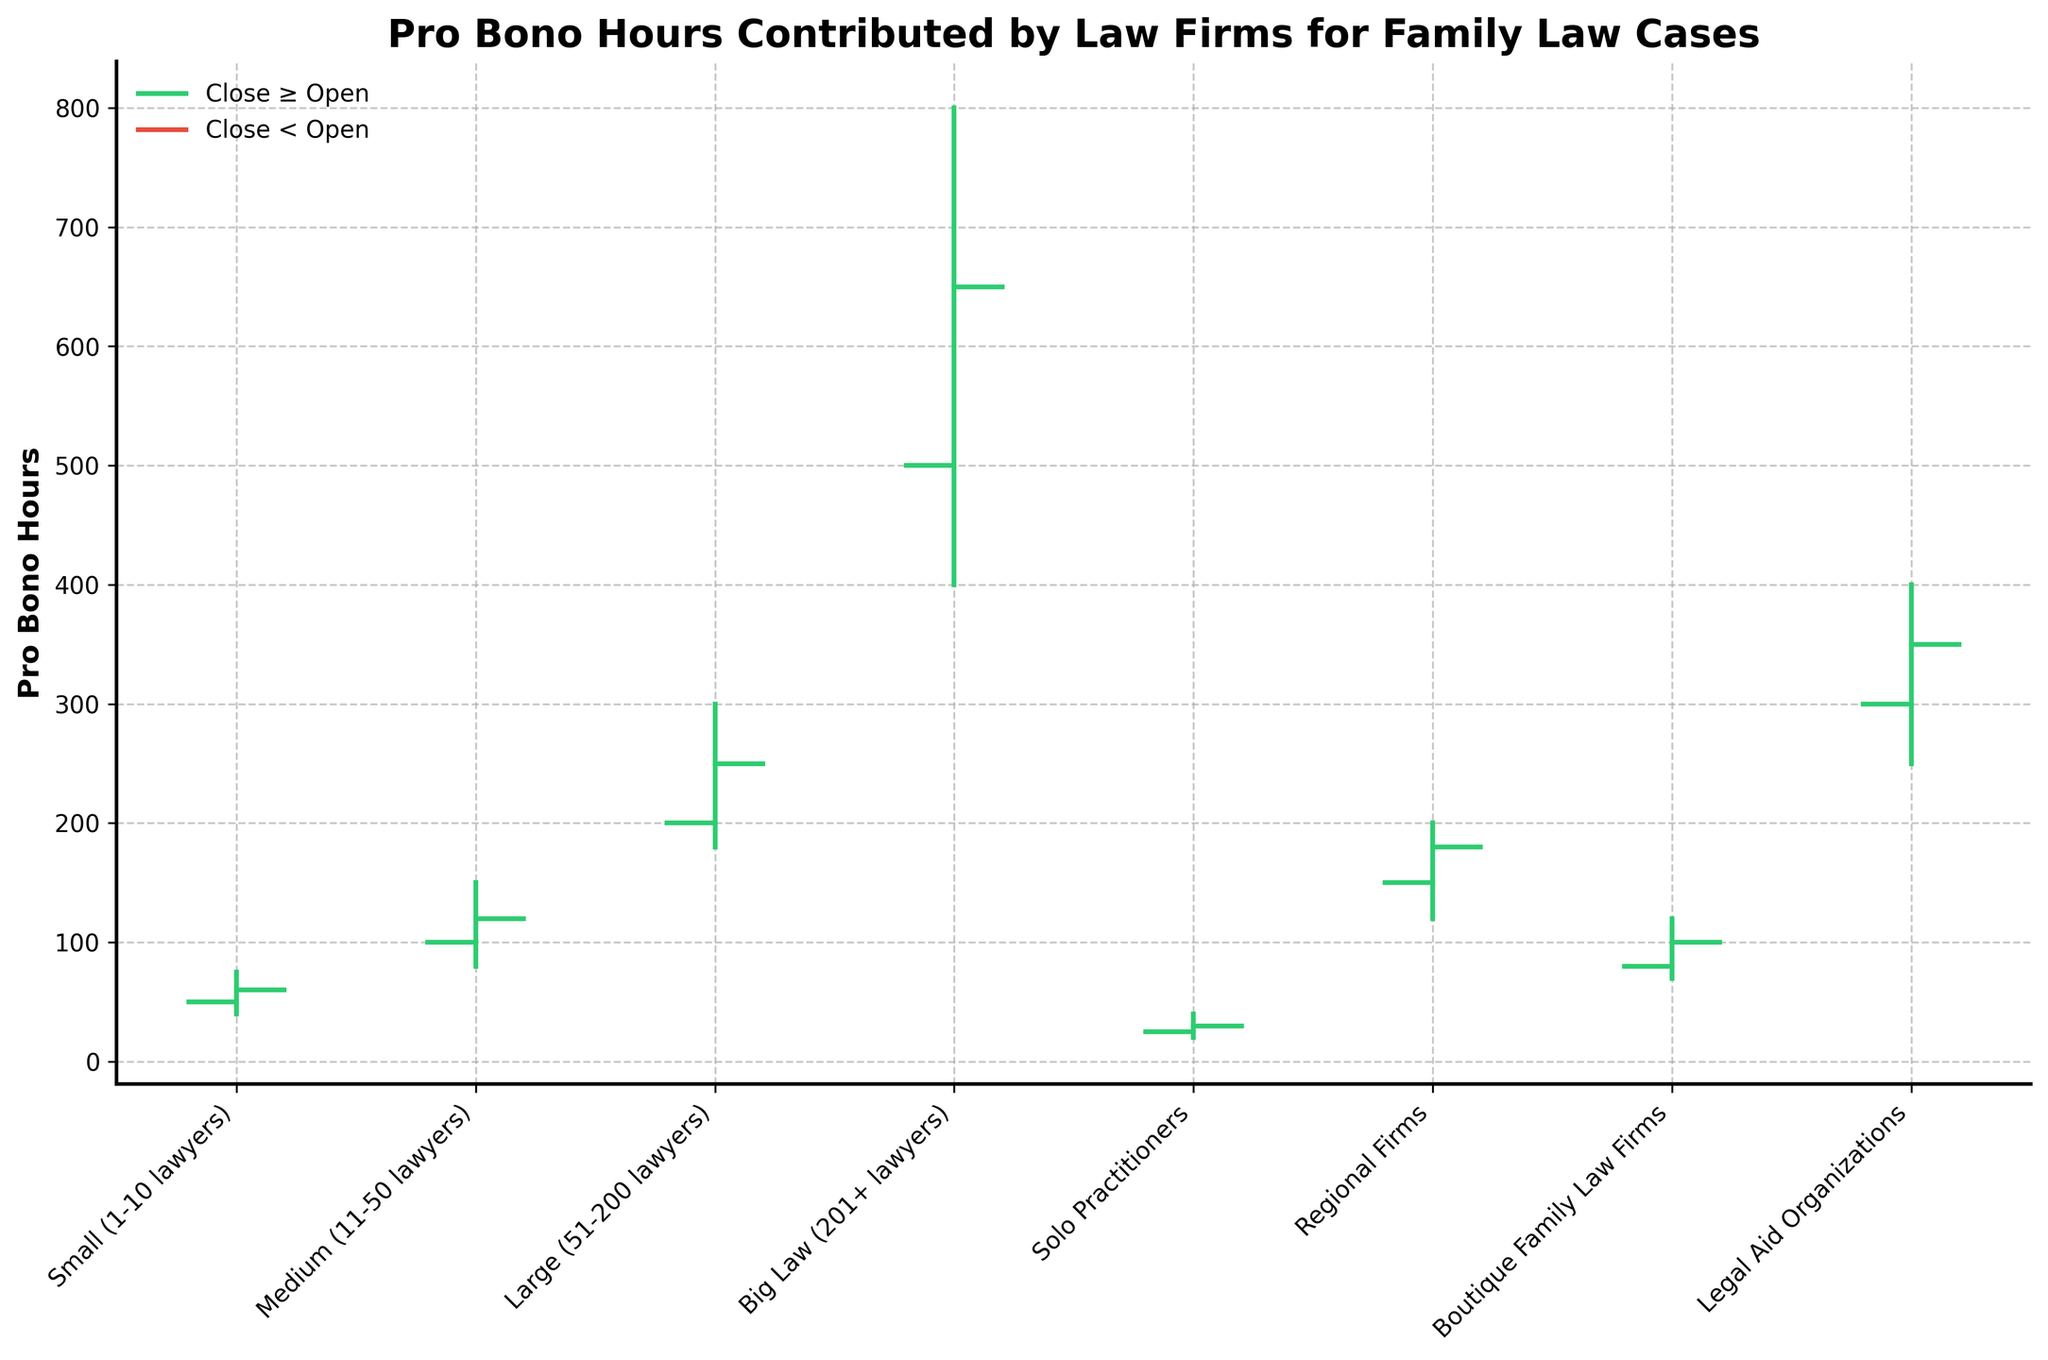What is the title of the figure? The title is usually found at the top of the figure and typically is in a larger font size, making it easy to identify.
Answer: Pro Bono Hours Contributed by Law Firms for Family Law Cases Which firm size category has the highest 'High' value? By examining the figure, we see that the category with the highest maximum pro bono hours has the highest vertical line endpoint. In this case, it is the 'Big Law (201+ lawyers)' category.
Answer: Big Law (201+ lawyers) How many categories of firm sizes are depicted in the figure? The number of categories can be determined by counting the horizontal ticks or labels along the x-axis, which represent different firm sizes.
Answer: 8 Which two firm size categories have close values greater than their open values? To find this, look for the green segments in the chart, as green indicates Close ≥ Open. Here, the 'Medium (11-50 lawyers)' and 'Legal Aid Organizations' categories are green.
Answer: Medium (11-50 lawyers), Legal Aid Organizations What is the range of pro bono hours for 'Large (51-200 lawyers)' firms? The range can be determined by finding the difference between the 'High' and 'Low' values. For 'Large (51-200 lawyers)', it's 300 - 180.
Answer: 120 For which firm size does the 'Low' value match its 'Close' value? Here, you need to identify the firm size where the bottom point of the vertical line (Low) is the same as the endpoint of the closing horizontal line (Close). For 'Regional Firms', this holds true with 'Low' and 'Close' both being 180 hours.
Answer: Regional Firms What is the total of the 'Close' values across all firm sizes? To find the total, add up all the Close values from the figure: 60 + 120 + 250 + 650 + 30 + 180 + 100 + 350 = 1740 hours.
Answer: 1740 hours Which two firm sizes have their 'Close' values between 100 and 200? Compare the 'Close' values and identify which ones fall in the range of 100 to 200. 'Medium (11-50 lawyers)' with 120 and 'Boutique Family Law Firms' with 100 fit this criteria.
Answer: Medium (11-50 lawyers), Boutique Family Law Firms How much greater is the 'High' value for 'Big Law' compared to 'Legal Aid Organizations'? Subtract the 'High' value of 'Legal Aid Organizations' from 'Big Law': 800 - 400.
Answer: 400 Which firm size category has the smallest difference between its 'Open' and 'Close' values? Evaluate the absolute differences between the 'Open' and 'Close' values for each category, and identify the smallest. 'Solo Practitioners' has a difference of 5 (30-25) which is the smallest.
Answer: Solo Practitioners 